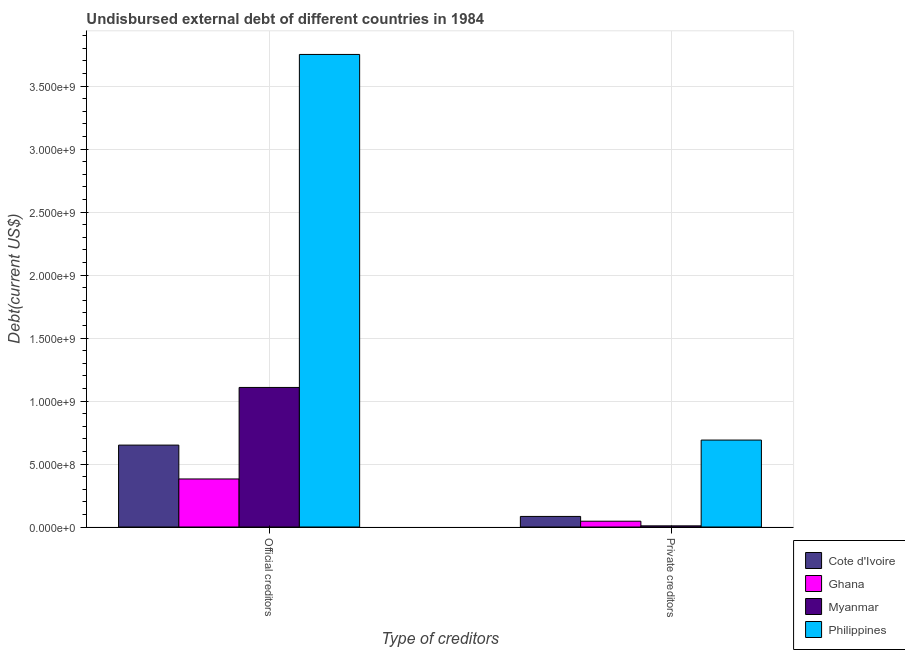Are the number of bars per tick equal to the number of legend labels?
Your answer should be compact. Yes. How many bars are there on the 2nd tick from the right?
Keep it short and to the point. 4. What is the label of the 2nd group of bars from the left?
Your response must be concise. Private creditors. What is the undisbursed external debt of private creditors in Cote d'Ivoire?
Ensure brevity in your answer.  8.40e+07. Across all countries, what is the maximum undisbursed external debt of official creditors?
Ensure brevity in your answer.  3.75e+09. Across all countries, what is the minimum undisbursed external debt of official creditors?
Your response must be concise. 3.81e+08. In which country was the undisbursed external debt of private creditors minimum?
Offer a very short reply. Myanmar. What is the total undisbursed external debt of official creditors in the graph?
Your answer should be compact. 5.89e+09. What is the difference between the undisbursed external debt of private creditors in Cote d'Ivoire and that in Myanmar?
Provide a short and direct response. 7.49e+07. What is the difference between the undisbursed external debt of private creditors in Myanmar and the undisbursed external debt of official creditors in Ghana?
Ensure brevity in your answer.  -3.72e+08. What is the average undisbursed external debt of private creditors per country?
Keep it short and to the point. 2.07e+08. What is the difference between the undisbursed external debt of official creditors and undisbursed external debt of private creditors in Myanmar?
Keep it short and to the point. 1.10e+09. What is the ratio of the undisbursed external debt of official creditors in Myanmar to that in Ghana?
Give a very brief answer. 2.9. In how many countries, is the undisbursed external debt of official creditors greater than the average undisbursed external debt of official creditors taken over all countries?
Your answer should be very brief. 1. How many bars are there?
Provide a short and direct response. 8. Are all the bars in the graph horizontal?
Provide a succinct answer. No. What is the difference between two consecutive major ticks on the Y-axis?
Your answer should be compact. 5.00e+08. Does the graph contain grids?
Your response must be concise. Yes. Where does the legend appear in the graph?
Offer a very short reply. Bottom right. How are the legend labels stacked?
Your answer should be compact. Vertical. What is the title of the graph?
Provide a succinct answer. Undisbursed external debt of different countries in 1984. Does "Tonga" appear as one of the legend labels in the graph?
Provide a short and direct response. No. What is the label or title of the X-axis?
Offer a terse response. Type of creditors. What is the label or title of the Y-axis?
Ensure brevity in your answer.  Debt(current US$). What is the Debt(current US$) in Cote d'Ivoire in Official creditors?
Your response must be concise. 6.50e+08. What is the Debt(current US$) of Ghana in Official creditors?
Your answer should be very brief. 3.81e+08. What is the Debt(current US$) of Myanmar in Official creditors?
Your answer should be compact. 1.11e+09. What is the Debt(current US$) in Philippines in Official creditors?
Offer a very short reply. 3.75e+09. What is the Debt(current US$) in Cote d'Ivoire in Private creditors?
Offer a terse response. 8.40e+07. What is the Debt(current US$) in Ghana in Private creditors?
Your response must be concise. 4.60e+07. What is the Debt(current US$) of Myanmar in Private creditors?
Your answer should be very brief. 9.16e+06. What is the Debt(current US$) in Philippines in Private creditors?
Your answer should be very brief. 6.90e+08. Across all Type of creditors, what is the maximum Debt(current US$) in Cote d'Ivoire?
Offer a terse response. 6.50e+08. Across all Type of creditors, what is the maximum Debt(current US$) in Ghana?
Offer a terse response. 3.81e+08. Across all Type of creditors, what is the maximum Debt(current US$) of Myanmar?
Make the answer very short. 1.11e+09. Across all Type of creditors, what is the maximum Debt(current US$) of Philippines?
Your answer should be compact. 3.75e+09. Across all Type of creditors, what is the minimum Debt(current US$) of Cote d'Ivoire?
Your answer should be very brief. 8.40e+07. Across all Type of creditors, what is the minimum Debt(current US$) in Ghana?
Keep it short and to the point. 4.60e+07. Across all Type of creditors, what is the minimum Debt(current US$) of Myanmar?
Keep it short and to the point. 9.16e+06. Across all Type of creditors, what is the minimum Debt(current US$) in Philippines?
Keep it short and to the point. 6.90e+08. What is the total Debt(current US$) in Cote d'Ivoire in the graph?
Provide a succinct answer. 7.34e+08. What is the total Debt(current US$) of Ghana in the graph?
Your answer should be compact. 4.27e+08. What is the total Debt(current US$) of Myanmar in the graph?
Your response must be concise. 1.12e+09. What is the total Debt(current US$) of Philippines in the graph?
Your answer should be very brief. 4.44e+09. What is the difference between the Debt(current US$) of Cote d'Ivoire in Official creditors and that in Private creditors?
Keep it short and to the point. 5.66e+08. What is the difference between the Debt(current US$) in Ghana in Official creditors and that in Private creditors?
Make the answer very short. 3.35e+08. What is the difference between the Debt(current US$) in Myanmar in Official creditors and that in Private creditors?
Keep it short and to the point. 1.10e+09. What is the difference between the Debt(current US$) in Philippines in Official creditors and that in Private creditors?
Provide a short and direct response. 3.06e+09. What is the difference between the Debt(current US$) in Cote d'Ivoire in Official creditors and the Debt(current US$) in Ghana in Private creditors?
Offer a very short reply. 6.04e+08. What is the difference between the Debt(current US$) of Cote d'Ivoire in Official creditors and the Debt(current US$) of Myanmar in Private creditors?
Your answer should be very brief. 6.41e+08. What is the difference between the Debt(current US$) of Cote d'Ivoire in Official creditors and the Debt(current US$) of Philippines in Private creditors?
Provide a succinct answer. -4.00e+07. What is the difference between the Debt(current US$) of Ghana in Official creditors and the Debt(current US$) of Myanmar in Private creditors?
Offer a terse response. 3.72e+08. What is the difference between the Debt(current US$) in Ghana in Official creditors and the Debt(current US$) in Philippines in Private creditors?
Offer a very short reply. -3.09e+08. What is the difference between the Debt(current US$) in Myanmar in Official creditors and the Debt(current US$) in Philippines in Private creditors?
Keep it short and to the point. 4.18e+08. What is the average Debt(current US$) in Cote d'Ivoire per Type of creditors?
Provide a short and direct response. 3.67e+08. What is the average Debt(current US$) in Ghana per Type of creditors?
Your answer should be compact. 2.14e+08. What is the average Debt(current US$) of Myanmar per Type of creditors?
Your answer should be very brief. 5.59e+08. What is the average Debt(current US$) of Philippines per Type of creditors?
Make the answer very short. 2.22e+09. What is the difference between the Debt(current US$) of Cote d'Ivoire and Debt(current US$) of Ghana in Official creditors?
Your answer should be compact. 2.69e+08. What is the difference between the Debt(current US$) in Cote d'Ivoire and Debt(current US$) in Myanmar in Official creditors?
Offer a terse response. -4.58e+08. What is the difference between the Debt(current US$) in Cote d'Ivoire and Debt(current US$) in Philippines in Official creditors?
Make the answer very short. -3.10e+09. What is the difference between the Debt(current US$) in Ghana and Debt(current US$) in Myanmar in Official creditors?
Give a very brief answer. -7.26e+08. What is the difference between the Debt(current US$) of Ghana and Debt(current US$) of Philippines in Official creditors?
Provide a short and direct response. -3.37e+09. What is the difference between the Debt(current US$) in Myanmar and Debt(current US$) in Philippines in Official creditors?
Make the answer very short. -2.64e+09. What is the difference between the Debt(current US$) of Cote d'Ivoire and Debt(current US$) of Ghana in Private creditors?
Provide a short and direct response. 3.80e+07. What is the difference between the Debt(current US$) of Cote d'Ivoire and Debt(current US$) of Myanmar in Private creditors?
Make the answer very short. 7.49e+07. What is the difference between the Debt(current US$) in Cote d'Ivoire and Debt(current US$) in Philippines in Private creditors?
Ensure brevity in your answer.  -6.06e+08. What is the difference between the Debt(current US$) in Ghana and Debt(current US$) in Myanmar in Private creditors?
Ensure brevity in your answer.  3.69e+07. What is the difference between the Debt(current US$) in Ghana and Debt(current US$) in Philippines in Private creditors?
Your answer should be very brief. -6.44e+08. What is the difference between the Debt(current US$) in Myanmar and Debt(current US$) in Philippines in Private creditors?
Make the answer very short. -6.81e+08. What is the ratio of the Debt(current US$) of Cote d'Ivoire in Official creditors to that in Private creditors?
Your response must be concise. 7.74. What is the ratio of the Debt(current US$) of Ghana in Official creditors to that in Private creditors?
Your answer should be compact. 8.29. What is the ratio of the Debt(current US$) of Myanmar in Official creditors to that in Private creditors?
Ensure brevity in your answer.  120.97. What is the ratio of the Debt(current US$) of Philippines in Official creditors to that in Private creditors?
Provide a short and direct response. 5.44. What is the difference between the highest and the second highest Debt(current US$) of Cote d'Ivoire?
Give a very brief answer. 5.66e+08. What is the difference between the highest and the second highest Debt(current US$) of Ghana?
Offer a terse response. 3.35e+08. What is the difference between the highest and the second highest Debt(current US$) in Myanmar?
Offer a terse response. 1.10e+09. What is the difference between the highest and the second highest Debt(current US$) in Philippines?
Give a very brief answer. 3.06e+09. What is the difference between the highest and the lowest Debt(current US$) in Cote d'Ivoire?
Make the answer very short. 5.66e+08. What is the difference between the highest and the lowest Debt(current US$) of Ghana?
Provide a short and direct response. 3.35e+08. What is the difference between the highest and the lowest Debt(current US$) of Myanmar?
Your answer should be very brief. 1.10e+09. What is the difference between the highest and the lowest Debt(current US$) of Philippines?
Provide a succinct answer. 3.06e+09. 